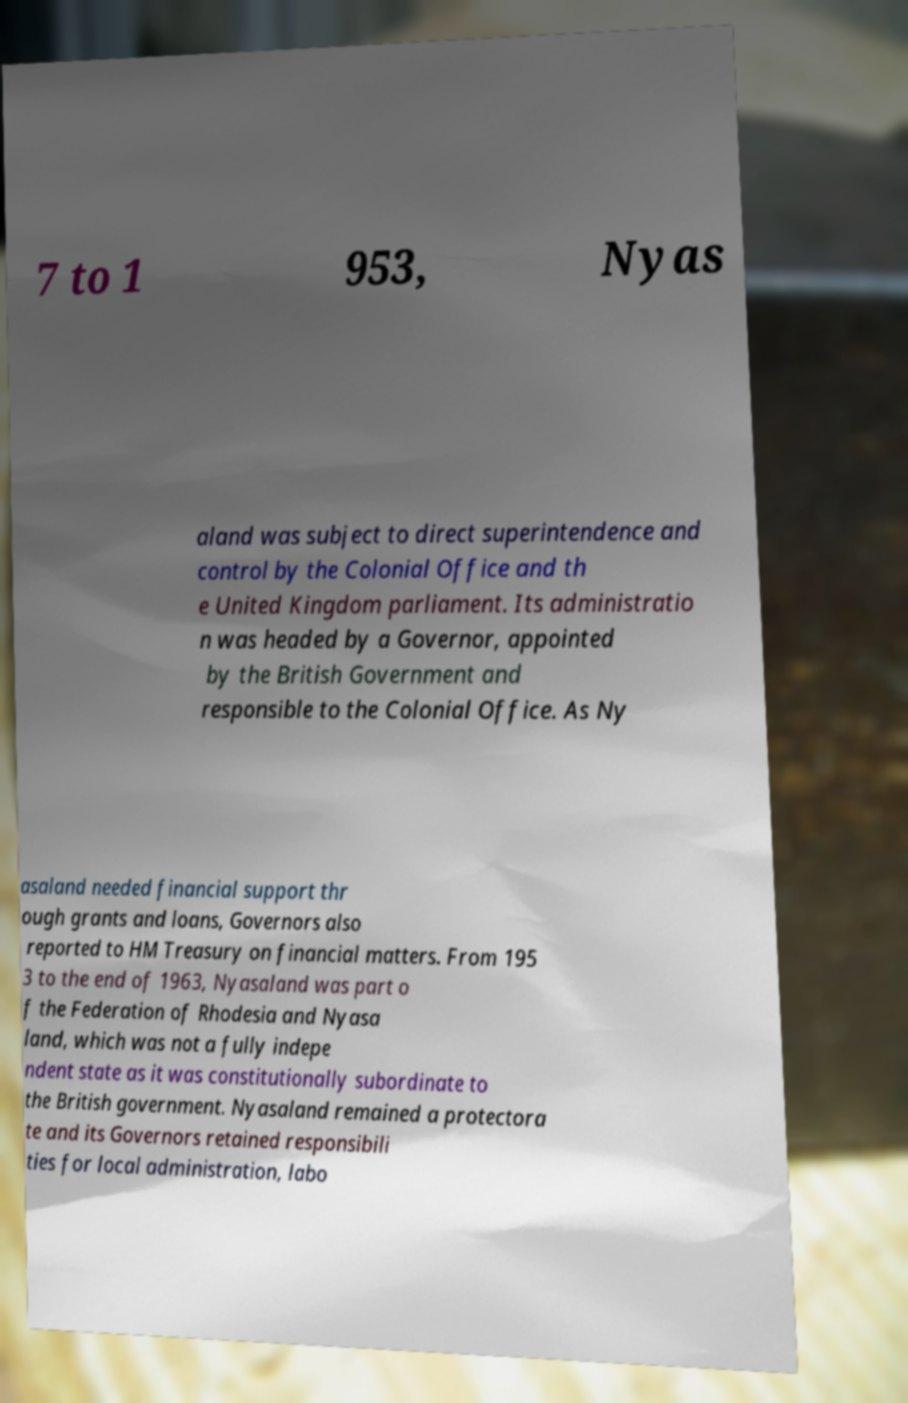Could you assist in decoding the text presented in this image and type it out clearly? 7 to 1 953, Nyas aland was subject to direct superintendence and control by the Colonial Office and th e United Kingdom parliament. Its administratio n was headed by a Governor, appointed by the British Government and responsible to the Colonial Office. As Ny asaland needed financial support thr ough grants and loans, Governors also reported to HM Treasury on financial matters. From 195 3 to the end of 1963, Nyasaland was part o f the Federation of Rhodesia and Nyasa land, which was not a fully indepe ndent state as it was constitutionally subordinate to the British government. Nyasaland remained a protectora te and its Governors retained responsibili ties for local administration, labo 